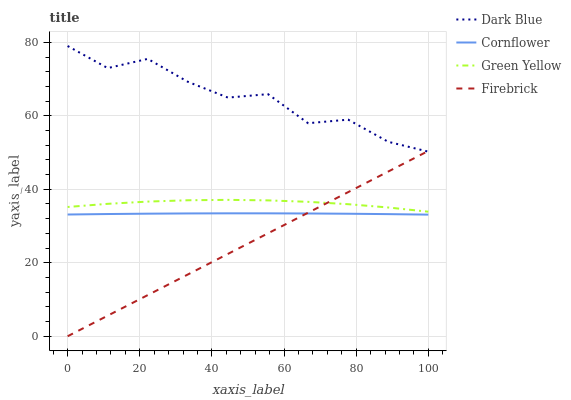Does Firebrick have the minimum area under the curve?
Answer yes or no. Yes. Does Dark Blue have the maximum area under the curve?
Answer yes or no. Yes. Does Green Yellow have the minimum area under the curve?
Answer yes or no. No. Does Green Yellow have the maximum area under the curve?
Answer yes or no. No. Is Firebrick the smoothest?
Answer yes or no. Yes. Is Dark Blue the roughest?
Answer yes or no. Yes. Is Green Yellow the smoothest?
Answer yes or no. No. Is Green Yellow the roughest?
Answer yes or no. No. Does Firebrick have the lowest value?
Answer yes or no. Yes. Does Green Yellow have the lowest value?
Answer yes or no. No. Does Dark Blue have the highest value?
Answer yes or no. Yes. Does Firebrick have the highest value?
Answer yes or no. No. Is Cornflower less than Green Yellow?
Answer yes or no. Yes. Is Dark Blue greater than Green Yellow?
Answer yes or no. Yes. Does Firebrick intersect Cornflower?
Answer yes or no. Yes. Is Firebrick less than Cornflower?
Answer yes or no. No. Is Firebrick greater than Cornflower?
Answer yes or no. No. Does Cornflower intersect Green Yellow?
Answer yes or no. No. 